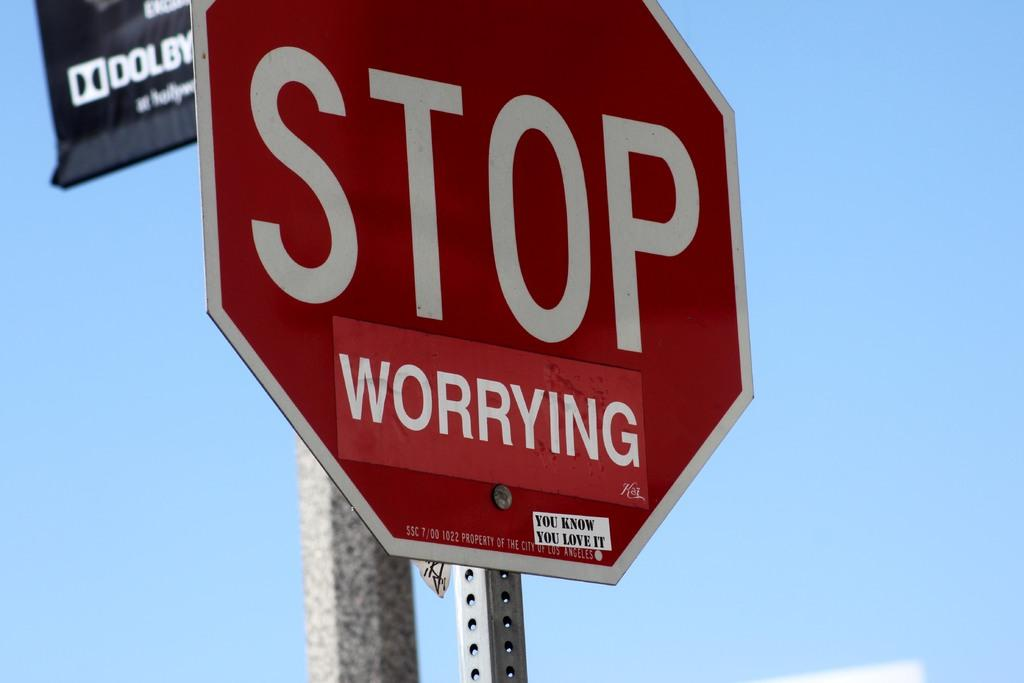<image>
Provide a brief description of the given image. A red sign with the words "Stop worrying" on it 